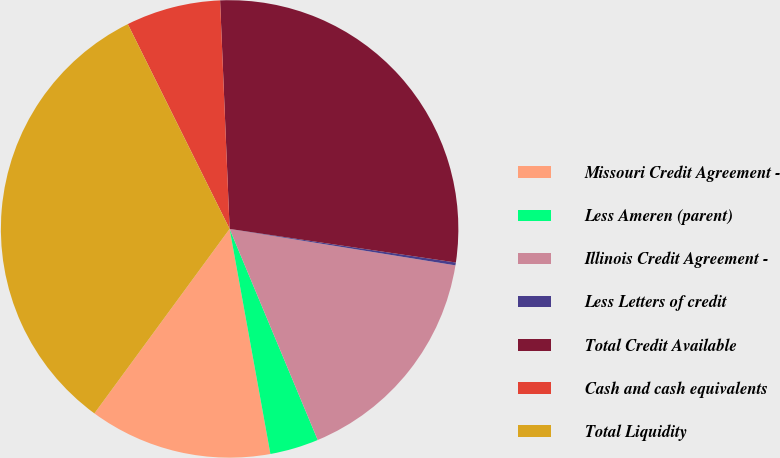Convert chart to OTSL. <chart><loc_0><loc_0><loc_500><loc_500><pie_chart><fcel>Missouri Credit Agreement -<fcel>Less Ameren (parent)<fcel>Illinois Credit Agreement -<fcel>Less Letters of credit<fcel>Total Credit Available<fcel>Cash and cash equivalents<fcel>Total Liquidity<nl><fcel>12.92%<fcel>3.44%<fcel>16.16%<fcel>0.2%<fcel>28.01%<fcel>6.68%<fcel>32.59%<nl></chart> 